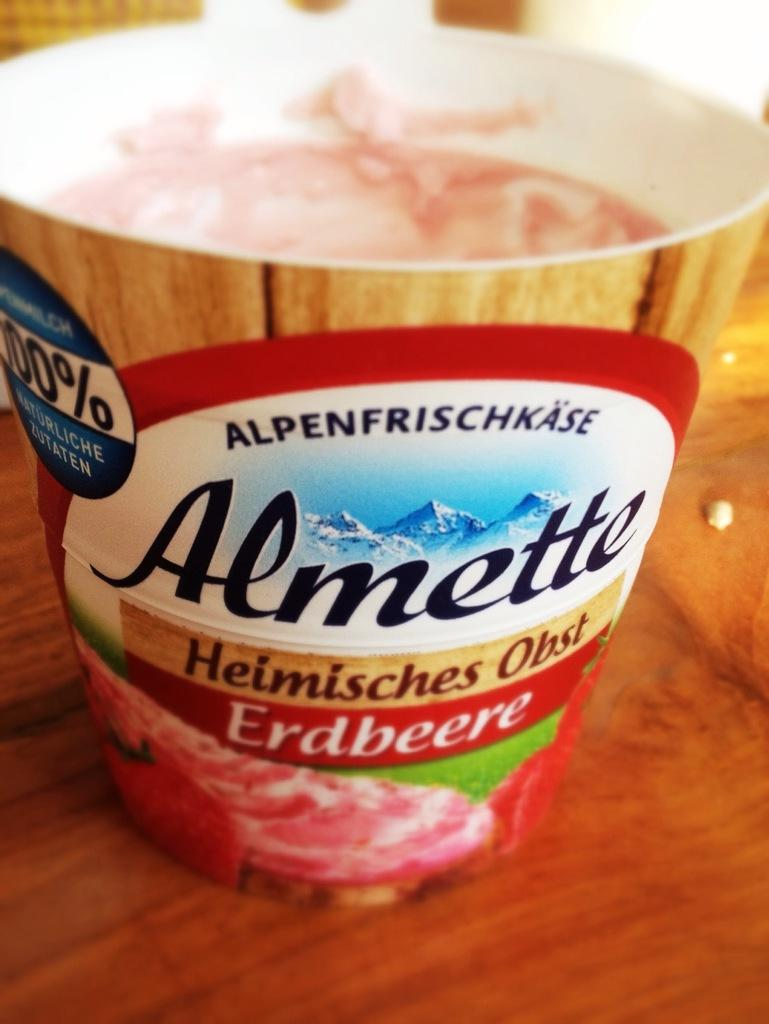What object is present in the image? There is a cup in the image. What is the cup placed on? The cup is on a wooden surface. What type of soup is being served in the cup in the image? There is no soup present in the image; it only shows a cup on a wooden surface. 